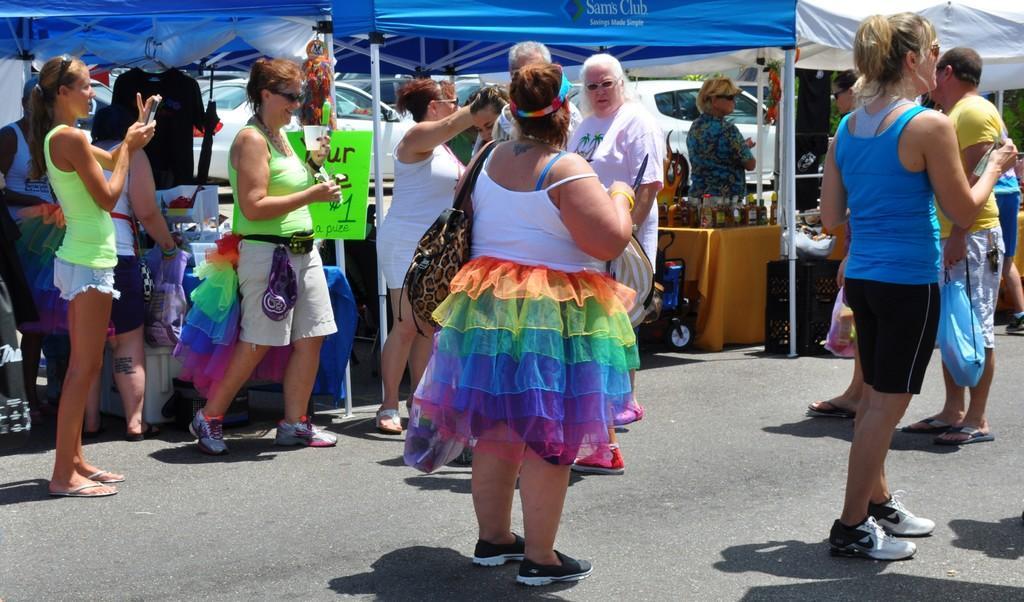Describe this image in one or two sentences. This is an outside view. In this image I can see many people are standing on the road. In the background there is a tent. Few people are standing under the tent and there are few tables and objects. In the background there are few cars. 